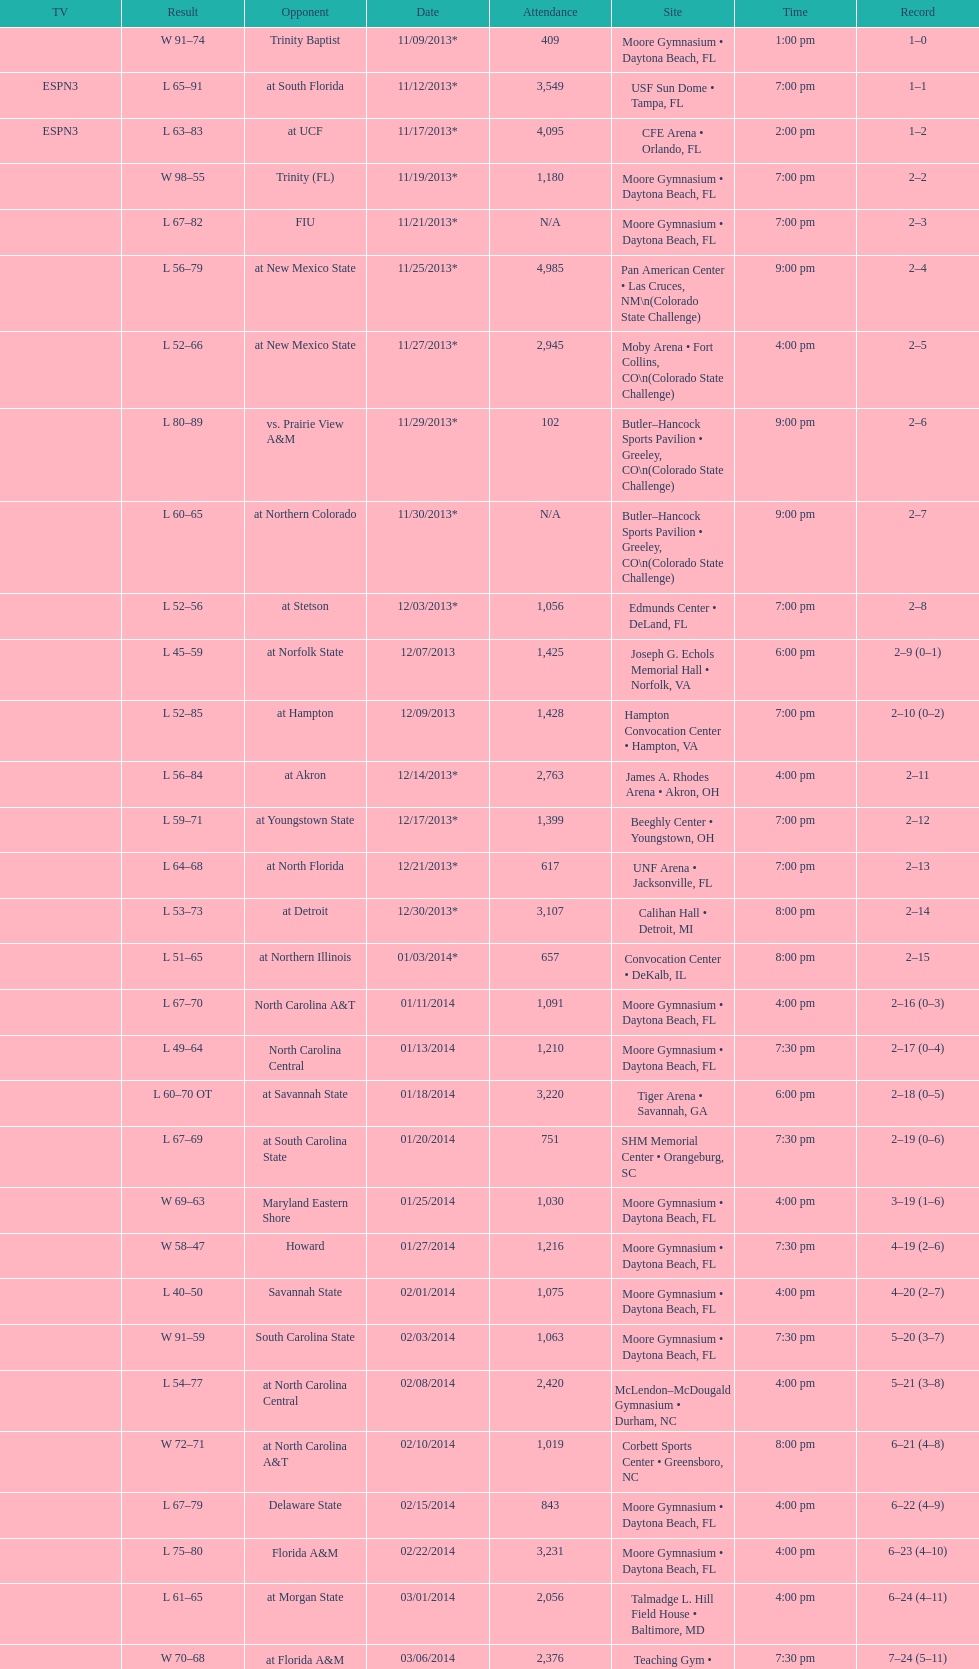Between fiu and northern colorado, which game occurred at a later time during the night? Northern Colorado. 